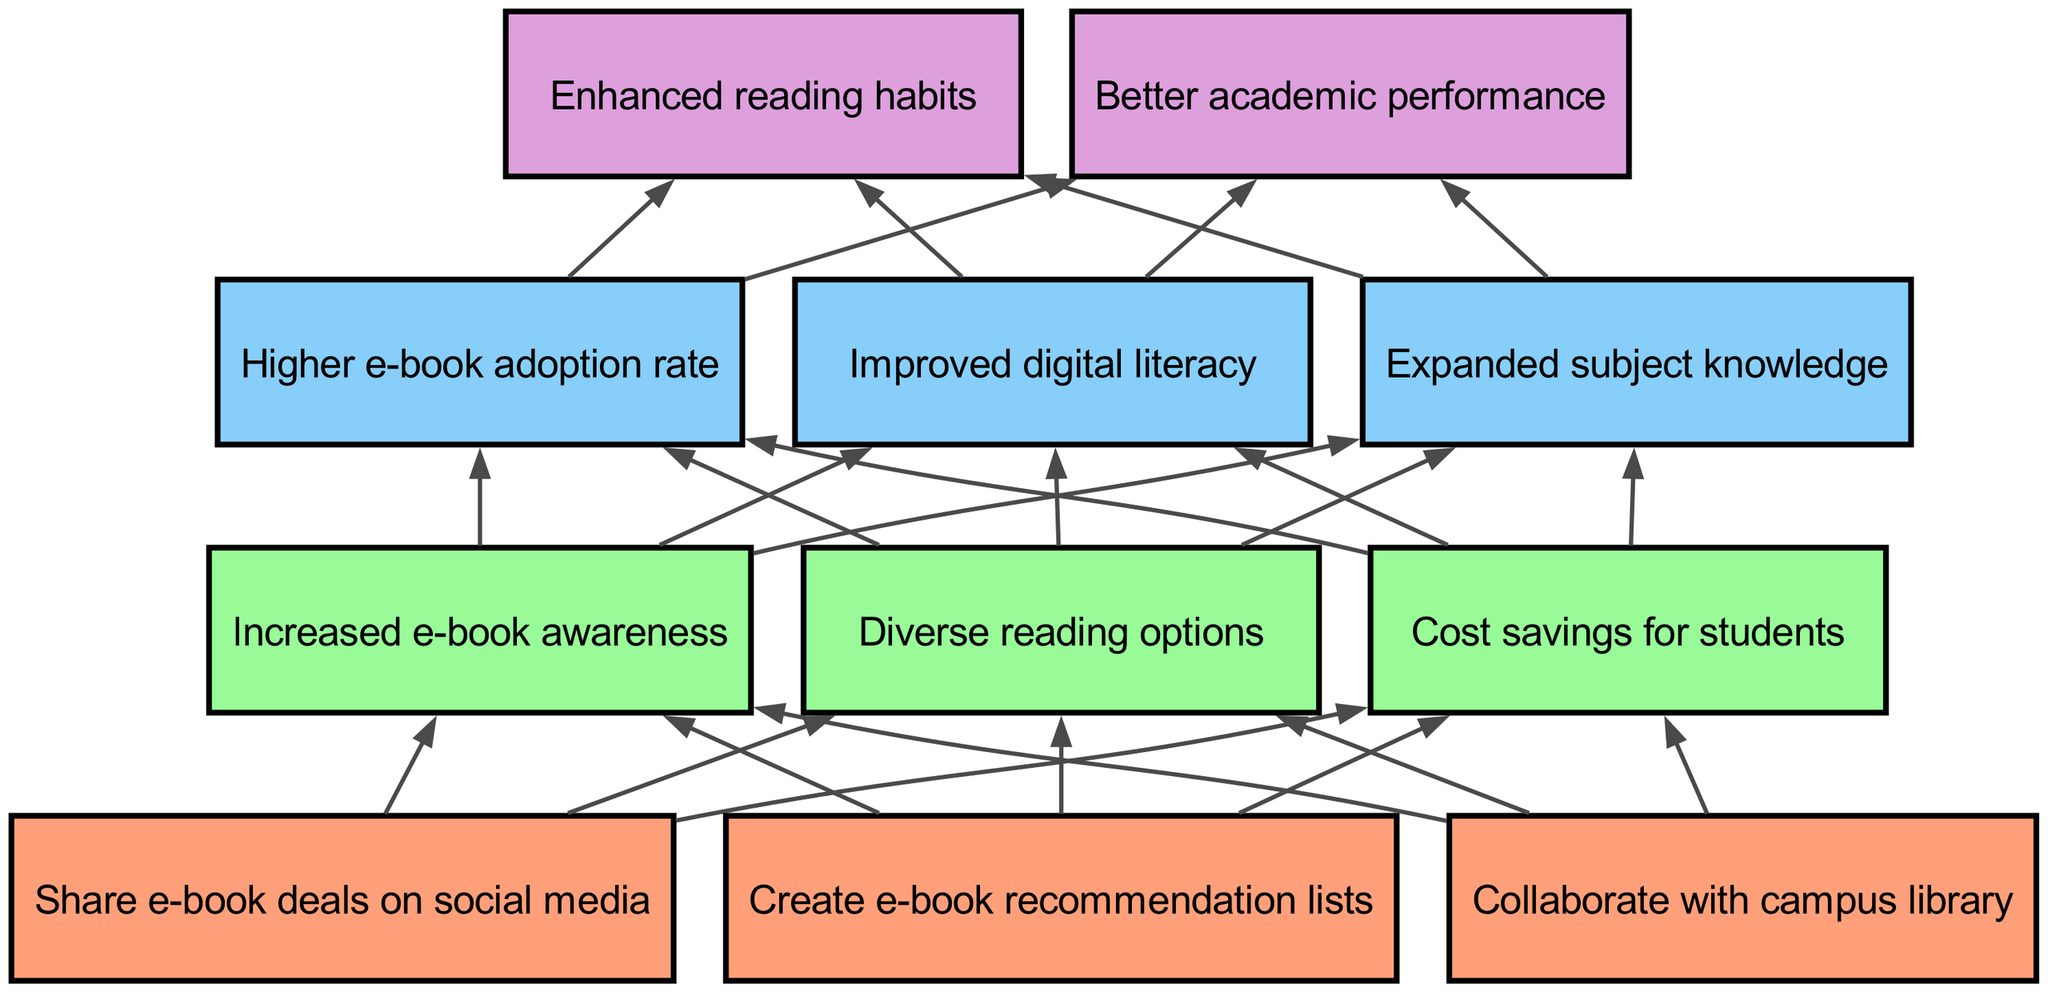What are the three actions listed at level 1? The diagram presents three actions at level 1: "Share e-book deals on social media," "Create e-book recommendation lists," and "Collaborate with campus library."
Answer: Share e-book deals on social media, Create e-book recommendation lists, Collaborate with campus library How many items are there in level 2? The diagram indicates two items in level 2, which are "Increased e-book awareness," "Diverse reading options," and "Cost savings for students."
Answer: 3 Which level includes "Enhanced reading habits"? "Enhanced reading habits" is located at level 4 of the diagram as a result of the flow from lower levels.
Answer: Level 4 What is the relationship between "Cost savings for students" and "Better academic performance"? "Cost savings for students" leads to "Higher e-book adoption rate," which then contributes to "Enhanced reading habits," ultimately resulting in "Better academic performance."
Answer: Through higher e-book adoption and enhanced reading habits How many edges are there connecting level 2 and level 3? The diagram shows three items in level 2, each connecting to three items in level 3, resulting in a total of nine edges between level 2 and level 3.
Answer: 9 What is the final outcome noted in level 4? The diagram concludes with the final outcome of "Better academic performance" as a result of the previous levels' influences.
Answer: Better academic performance Which item in level 3 corresponds to the item "Diverse reading options" in level 2? "Diverse reading options" leads to "Improved digital literacy" at level 3, demonstrating a direct connection in the flow.
Answer: Improved digital literacy What do all level 1 items contribute to? All items at level 1 contribute to level 2 outcomes, specifically increasing e-book awareness, offering diverse reading options, and providing cost savings for students.
Answer: Increased e-book awareness, Diverse reading options, Cost savings for students How is the flow of influence structured in this diagram? The influence flows from level 1 at the bottom, leading to level 2, then to level 3, and finally culminating in level 4, demonstrating a bottom-up approach to how e-book recommendations affect reading habits and academic performance.
Answer: Bottom-up flow from level 1 to level 4 